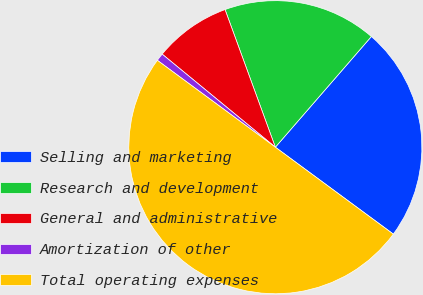Convert chart. <chart><loc_0><loc_0><loc_500><loc_500><pie_chart><fcel>Selling and marketing<fcel>Research and development<fcel>General and administrative<fcel>Amortization of other<fcel>Total operating expenses<nl><fcel>23.73%<fcel>16.95%<fcel>8.47%<fcel>0.85%<fcel>50.0%<nl></chart> 